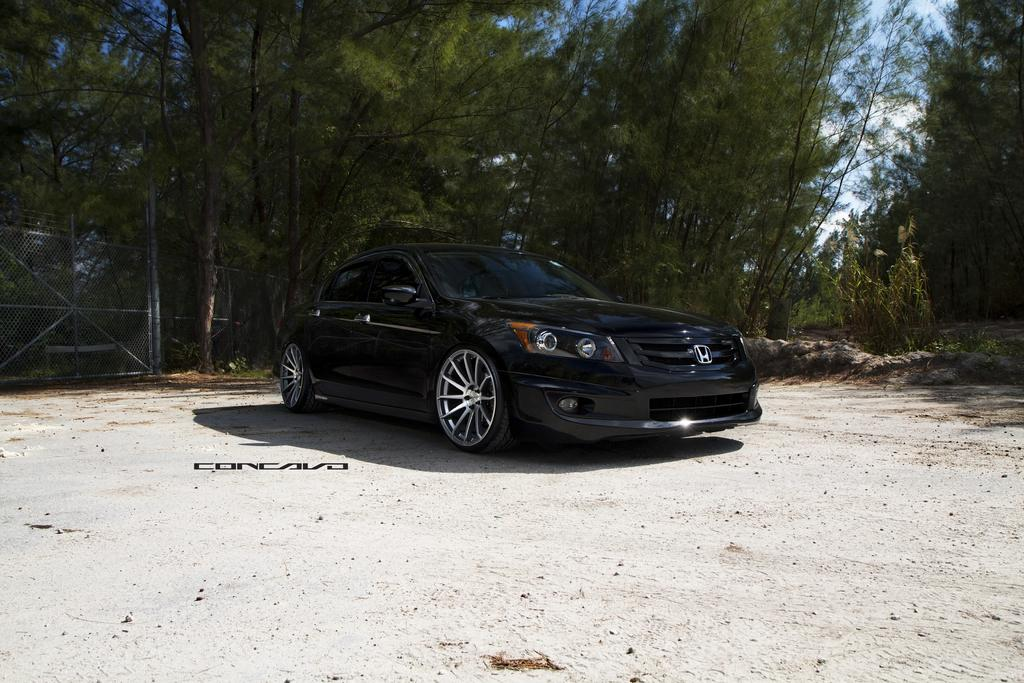What color is the car in the image? The car in the image is black. Where is the car located in the image? The car is on the ground. What can be seen in the background of the image? In the background of the image, there is a fence, poles, trees, and clouds visible in the sky. What type of earth can be seen in the image? There is no specific type of earth mentioned or visible in the image; it only shows a black car, a fence, poles, trees, and clouds in the sky. 